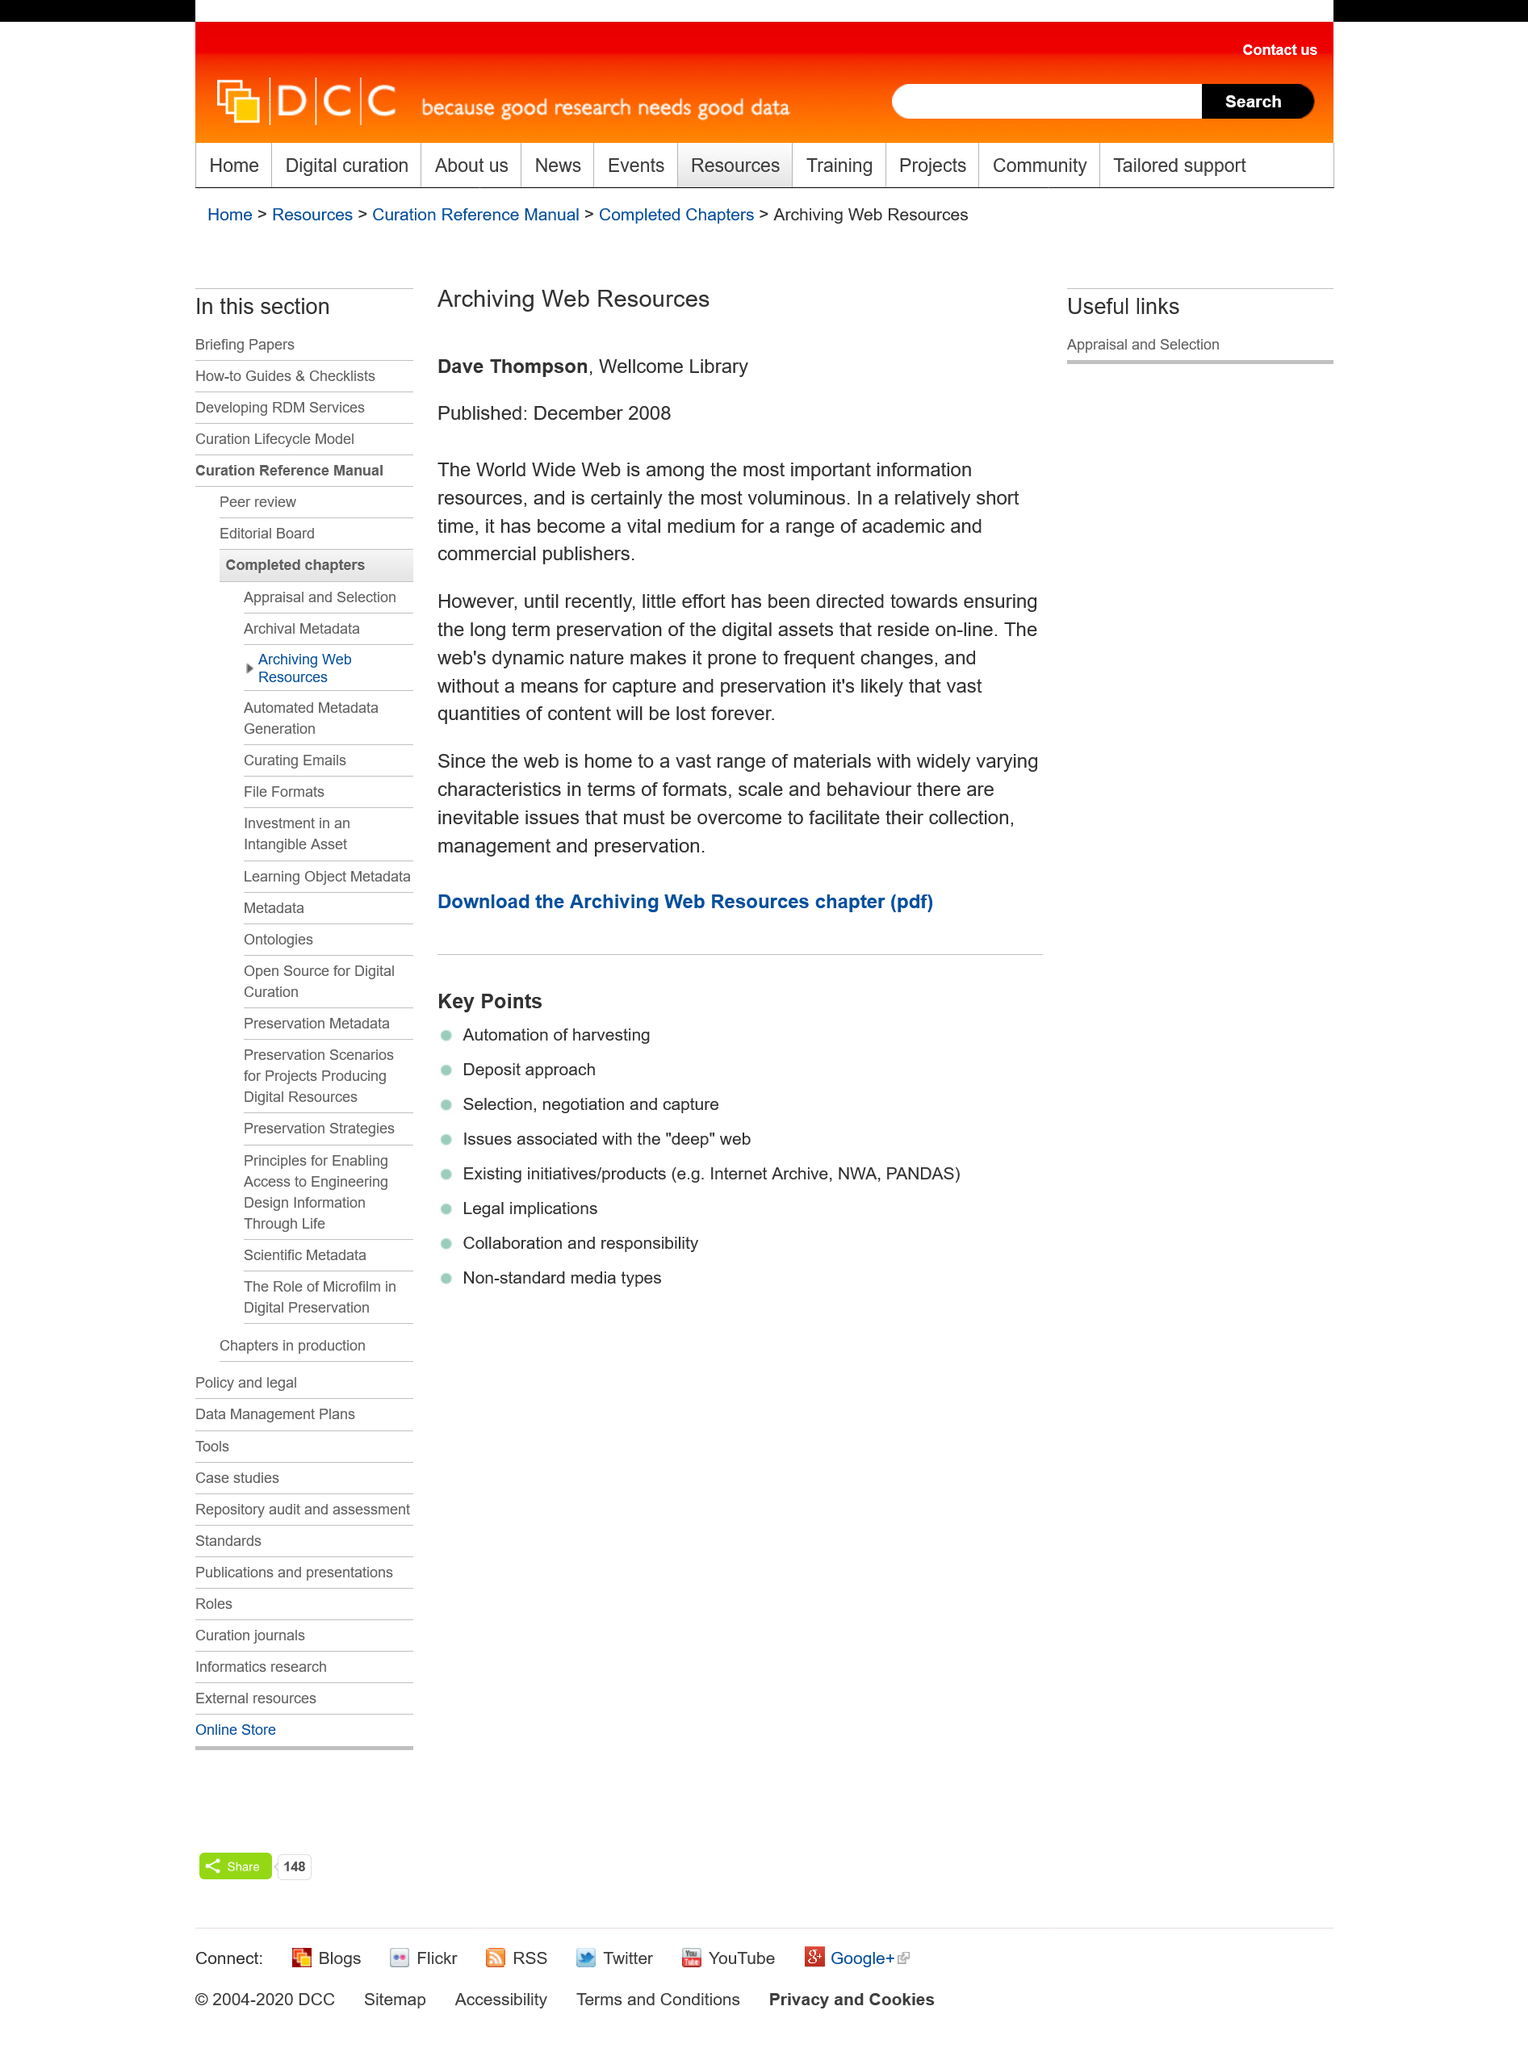List a handful of essential elements in this visual. The headline of this article is "Archiving Web Resources: A Comprehensive Guide to Preserving Online Information for Future Generations. This publication was released in December 2008. The person in charge of the Wellcome Library is named Dave Thompson. 